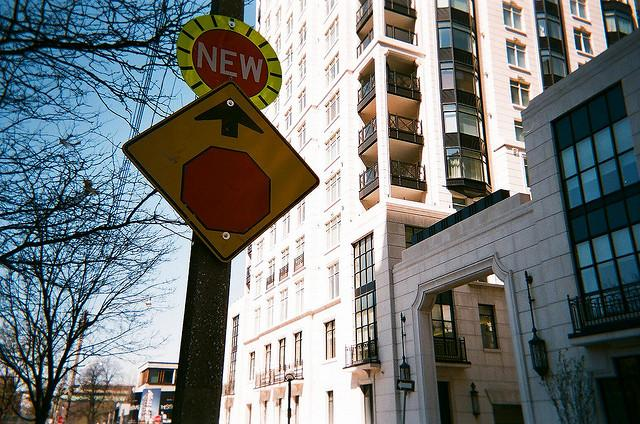The area outside the building would be described as what by a person? exterior 